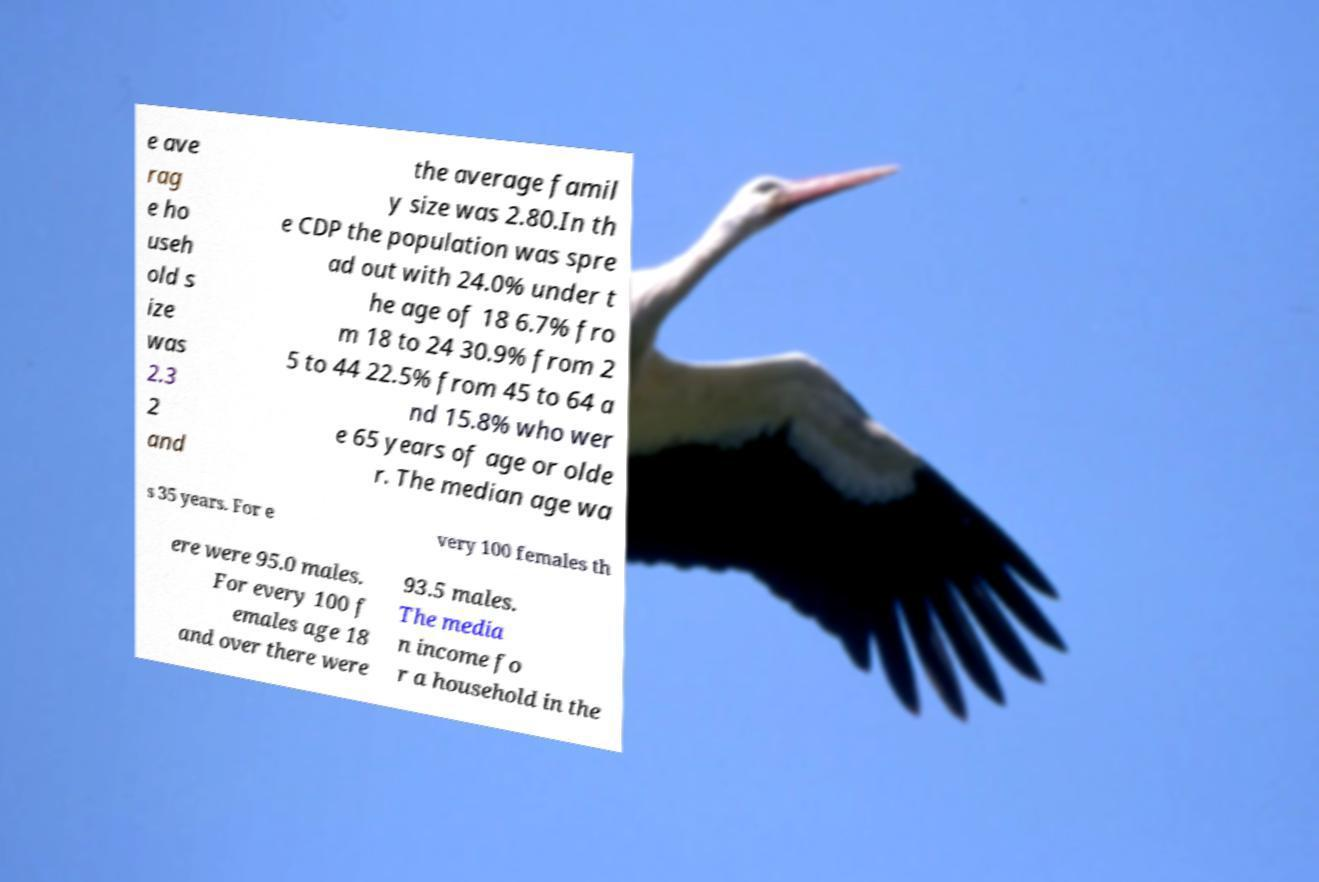Could you extract and type out the text from this image? e ave rag e ho useh old s ize was 2.3 2 and the average famil y size was 2.80.In th e CDP the population was spre ad out with 24.0% under t he age of 18 6.7% fro m 18 to 24 30.9% from 2 5 to 44 22.5% from 45 to 64 a nd 15.8% who wer e 65 years of age or olde r. The median age wa s 35 years. For e very 100 females th ere were 95.0 males. For every 100 f emales age 18 and over there were 93.5 males. The media n income fo r a household in the 